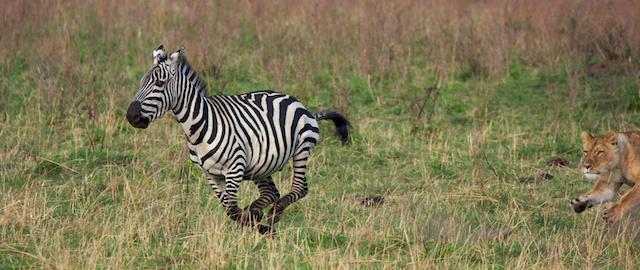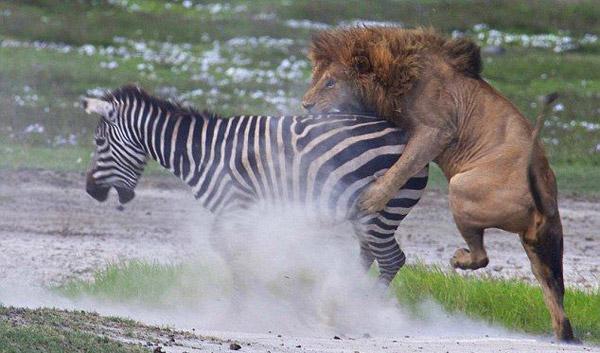The first image is the image on the left, the second image is the image on the right. Assess this claim about the two images: "The right image shows a lion attacking from the back end of a zebra, with clouds of dust created by the struggle.". Correct or not? Answer yes or no. Yes. The first image is the image on the left, the second image is the image on the right. Analyze the images presented: Is the assertion "The right image contains one zebras being attacked by a lion." valid? Answer yes or no. Yes. 